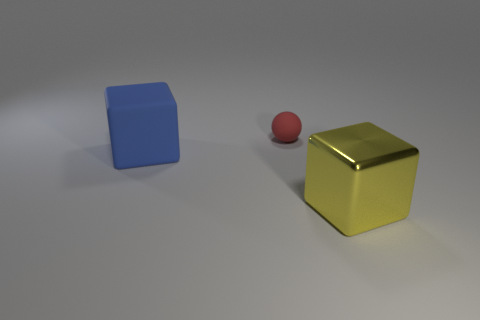The other object that is the same shape as the blue rubber thing is what color?
Keep it short and to the point. Yellow. What size is the rubber object that is the same shape as the large yellow metal thing?
Offer a terse response. Large. Are there any shiny blocks that are right of the cube that is to the left of the small ball?
Offer a very short reply. Yes. Are there more big matte things that are on the right side of the large blue rubber cube than red matte spheres that are to the left of the sphere?
Give a very brief answer. No. Is the color of the large cube that is in front of the big rubber thing the same as the thing that is on the left side of the tiny red sphere?
Your answer should be compact. No. Are there any large matte blocks on the right side of the blue matte block?
Keep it short and to the point. No. What material is the large yellow block?
Give a very brief answer. Metal. There is a large thing on the right side of the small thing; what is its shape?
Your answer should be compact. Cube. Is there a gray shiny cylinder that has the same size as the blue block?
Offer a very short reply. No. Is the material of the large thing to the left of the matte ball the same as the red ball?
Offer a very short reply. Yes. 